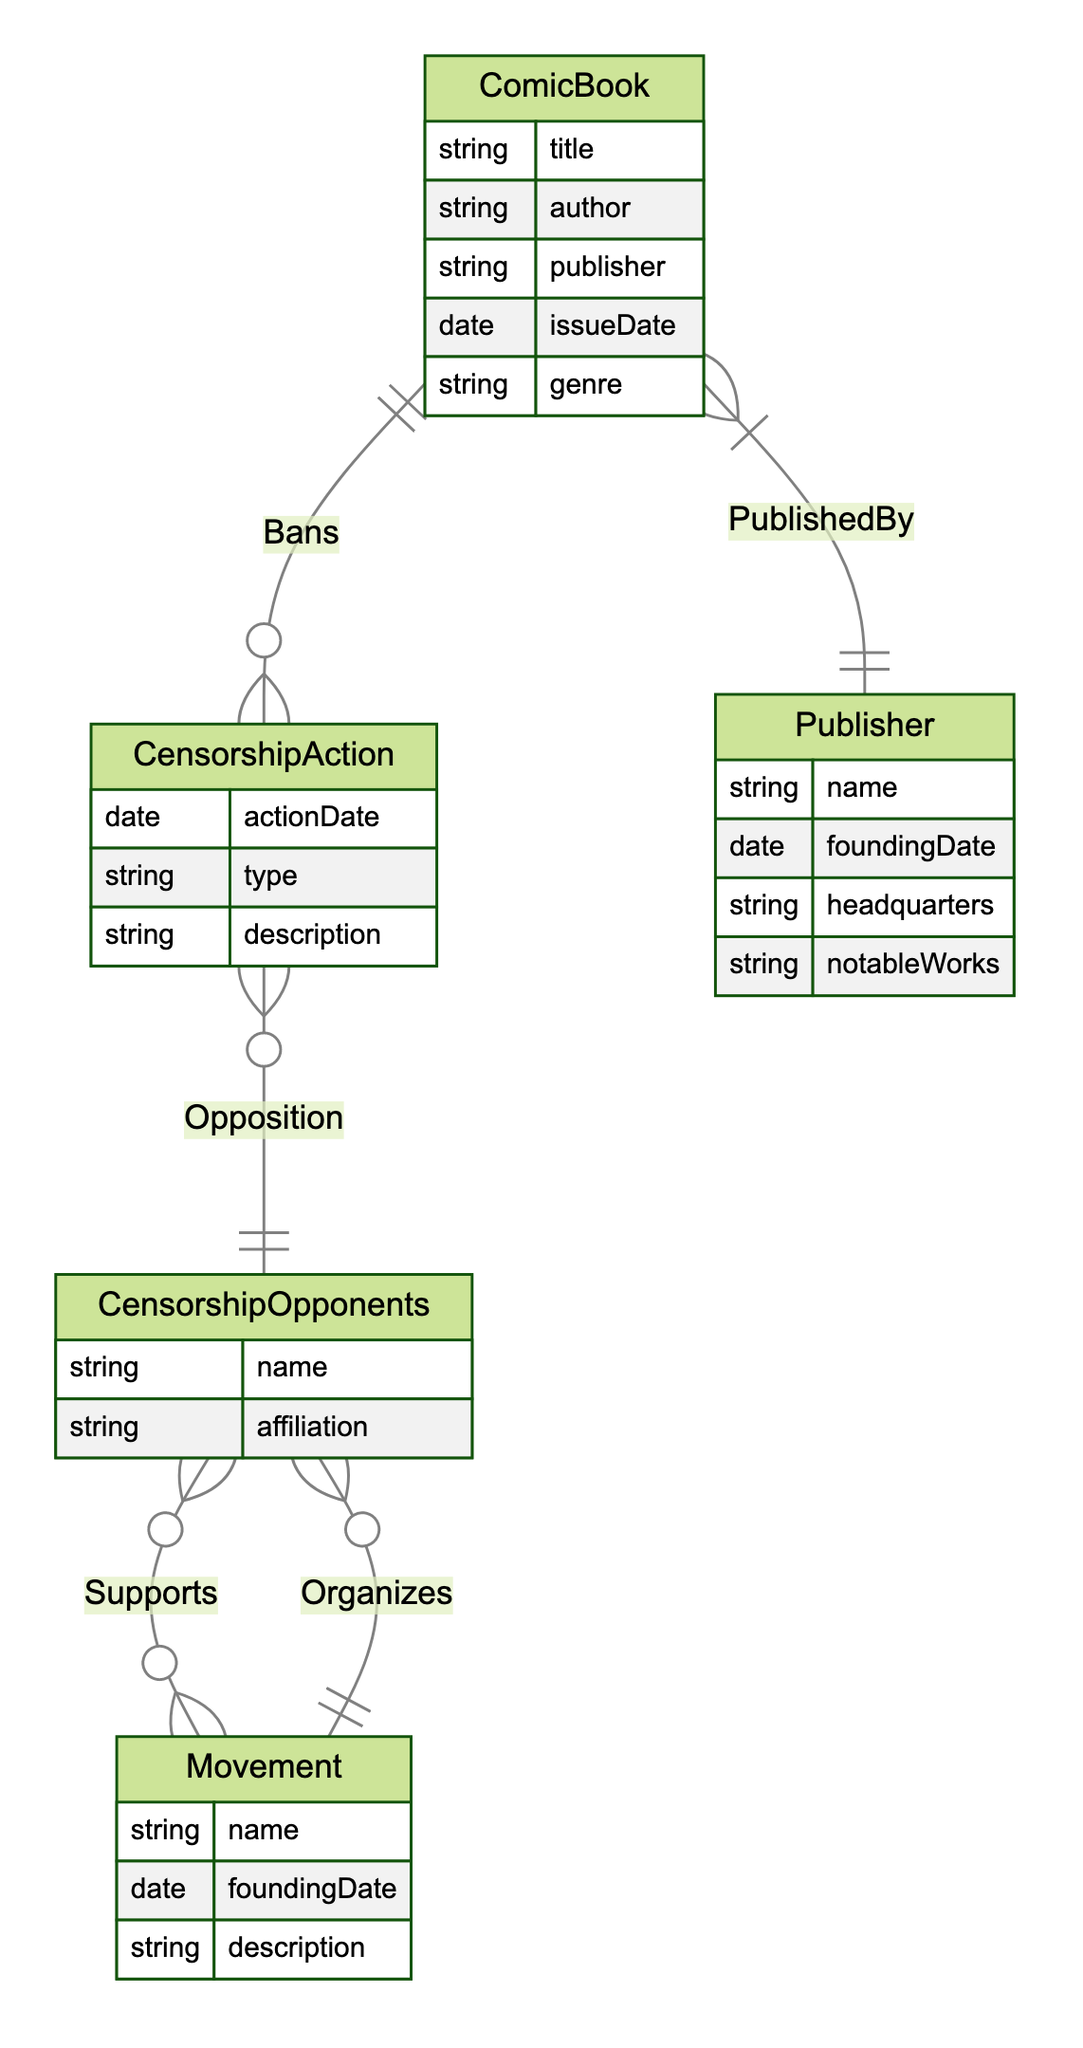What entity is linked to CensorshipAction by the relationship Bans? The relationship "Bans" connects the entities ComicBook and CensorshipAction, indicating that each CensorshipAction is related to multiple ComicBooks as one CensorshipAction can ban many ComicBooks.
Answer: ComicBook How many relationships does CensorshipOpponents have in this diagram? CensorshipOpponents is involved in two relationships: "Opposition" with CensorshipAction and "Supports" with Movement. Since there are two distinct connections, this entity has two relationships in the diagram.
Answer: 2 What is the cardinality of the relationship between Movement and CensorshipOpponents? The relationship "Supports" shows that CensorshipOpponents can support multiple Movements while a Movement is organized by multiple CensorshipOpponents, which means the cardinality for this relationship is N:M (many-to-many).
Answer: N:M What is the primary action that ComicBooks experience according to this diagram? The diagram suggests that the primary interaction for ComicBooks is that they can be banned through the relationship represented as "Bans" with CensorshipAction. Hence, this is the main action depicted for ComicBooks.
Answer: Bans Which entity organizes CensorshipOpponents according to the diagram? The diagram shows that Movement organizes CensorshipOpponents. This implies that each Movement has the ability to coordinate and manage groups of CensorshipOpponents as indicated by the "Organizes" relationship.
Answer: Movement What information does the Publisher entity contain in the diagram? The Publisher entity has specific attributes that include its name, founding date, headquarters, and notable works, providing details about publishers in relation to ComicBooks.
Answer: name, founding date, headquarters, notable works What type of action is indicated in the CensorshipAction entity? The CensorshipAction entity includes a type attribute, which describes the nature of the action taken against comic books, encapsulating various actions like bans and censorship measures.
Answer: action type How many entities are involved in the Bans relationship? The "Bans" relationship involves two entities, which are CensorshipAction and ComicBook, indicating the direct connection between the actions taken and the books affected.
Answer: 2 What does the relationship "PublishedBy" indicate regarding ComicBooks? The "PublishedBy" relationship indicates that ComicBooks are associated with one specific Publisher, meaning multiple ComicBooks can be published by the same entity but each ComicBook has only one Publisher associated with it.
Answer: Publisher 